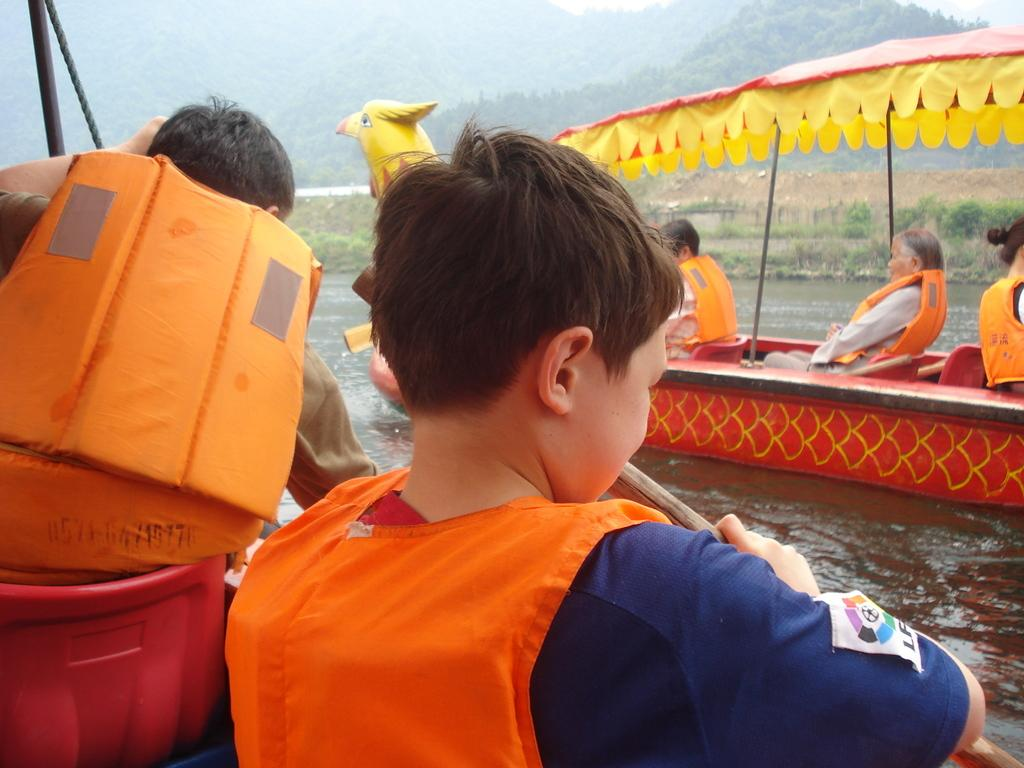Who or what can be seen in the image? There are people in the image. What is the primary setting of the image? There is water visible in the image. What type of vehicles are present in the image? There are boats in the image. What type of natural features can be seen in the image? Trees and hills are present in the image. What type of locket is the grandmother wearing around her neck in the image? There is no grandmother or locket present in the image. What color is the scarf that the person in the image is wearing? The provided facts do not mention any scarves or colors, so we cannot determine the color of a scarf in the image. 